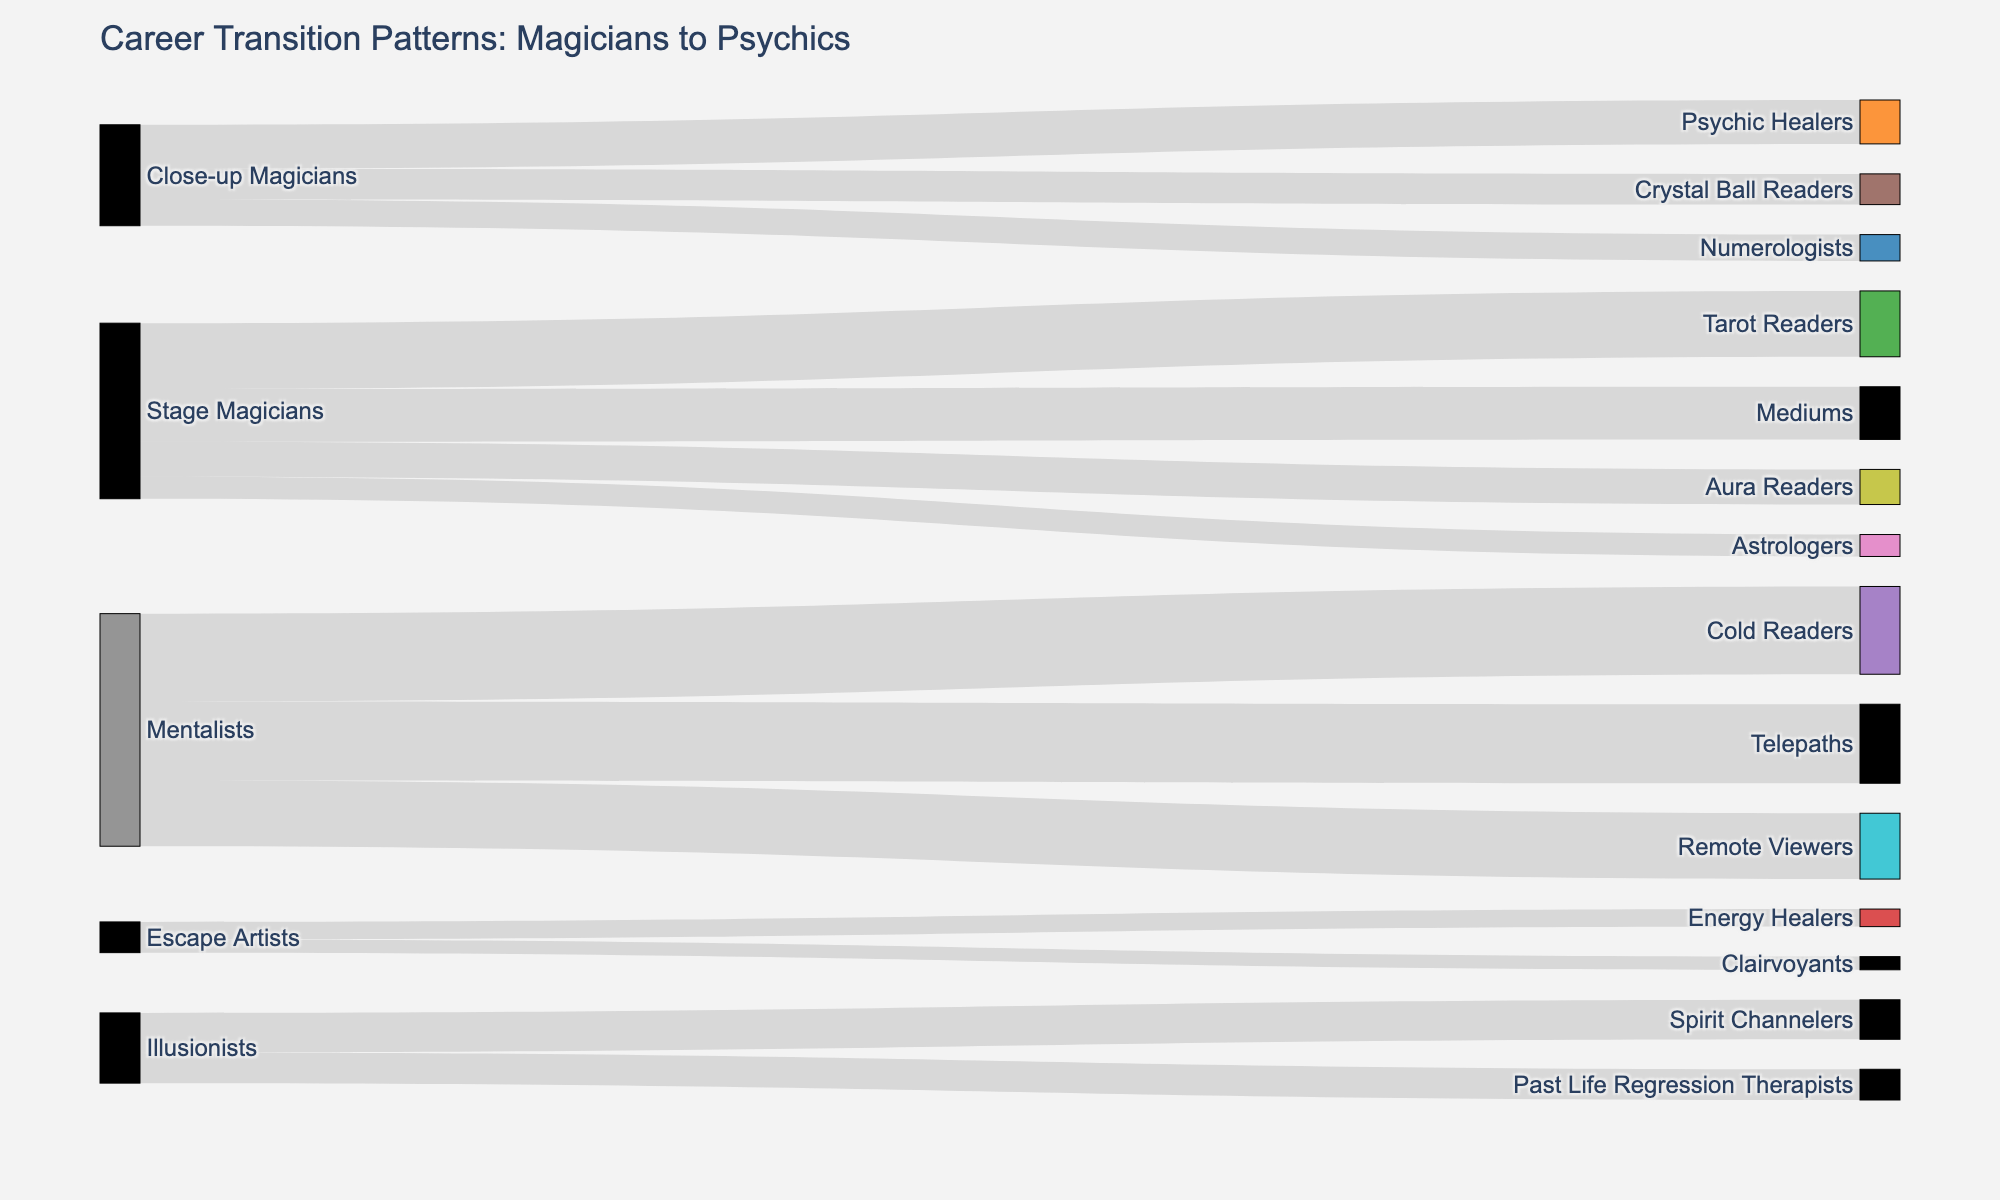Which type of magician most commonly transitions into becoming a Cold Reader? Mentalists most frequently transition into becoming Cold Readers as indicated by the source node "Mentalists" connecting to the target node "Cold Readers" with a value of 20, which is the highest in the diagram.
Answer: Mentalists What is the total number of magicians who transitioned to becoming Astrologers, Mediums, and Tarot Readers combined? By adding the values of the transitions to Astrologers (5), Mediums (12), and Tarot Readers (15), we get the total: 5 + 12 + 15 = 32.
Answer: 32 Which type of psychic profession receives the least number of former magicians? The target node "Clairvoyants" and "Energy Healers" each receive the lowest values of 3 and 4, respectively. Clairvoyants receive the least with a value of 3.
Answer: Clairvoyants Between Mentalists transitioning to Telepaths and Stage Magicians transitioning to Aura Readers, which has more transitions and by how much? Comparing the values, Mentalists to Telepaths have 18 transitions while Stage Magicians to Aura Readers have 8. The difference is 18 - 8 = 10.
Answer: Mentalists to Telepaths has 10 more How many transitions in total involve Stage Magicians as the source? Adding the values of all transitions from Stage Magicians: 15 (Tarot Readers) + 12 (Mediums) + 8 (Aura Readers) + 5 (Astrologers) = 40.
Answer: 40 Are there more transitions from Illusionists to Spirit Channelers or from Close-up Magicians to Crystal Ball Readers? The value for transitions from Illusionists to Spirit Channelers is 9, and from Close-up Magicians to Crystal Ball Readers is 7. Comparing, 9 is greater than 7.
Answer: Illusionists to Spirit Channelers Which type of magician transitions into the most different psychic professions? By counting the distinct target nodes connected to each source node: Stage Magicians (4), Close-up Magicians (3), Mentalists (3), Illusionists (2), and Escape Artists (2). Stage Magicians transition into the most different professions, which is 4.
Answer: Stage Magicians What is the average value of transitions involving Mentalists? Adding the values involving Mentalists: 20 (Cold Readers) + 18 (Telepaths) + 15 (Remote Viewers) = 53. Dividing by the number of transitions: 53 / 3 = 17.67.
Answer: 17.67 Considering the diagram, what proportion of former Mentalists became Telepaths? The total number of transitions involving Mentalists is 53. The number becoming Telepaths is 18. The proportion is 18 / 53 ≈ 0.34.
Answer: 0.34 